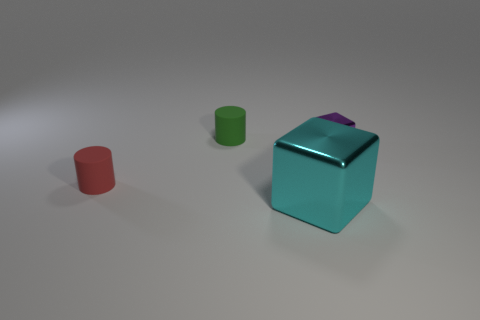There is a purple thing; is its size the same as the rubber cylinder that is behind the small purple metallic thing?
Provide a succinct answer. Yes. There is a cylinder on the right side of the small red rubber cylinder behind the cyan shiny thing; what is its color?
Keep it short and to the point. Green. Are there the same number of small purple metallic cubes in front of the tiny purple cube and purple metal cubes that are to the left of the cyan object?
Your answer should be very brief. Yes. Are the tiny cylinder that is in front of the tiny green thing and the large cyan block made of the same material?
Your answer should be very brief. No. There is a object that is left of the cyan block and behind the red rubber thing; what color is it?
Provide a succinct answer. Green. There is a small thing that is to the right of the cyan metallic object; how many tiny cylinders are in front of it?
Your answer should be very brief. 1. There is another object that is the same shape as the big cyan metallic thing; what material is it?
Ensure brevity in your answer.  Metal. What is the color of the big metal block?
Make the answer very short. Cyan. What number of objects are either small red matte cylinders or large gray cubes?
Offer a very short reply. 1. There is a matte thing to the left of the rubber thing behind the tiny purple block; what is its shape?
Your response must be concise. Cylinder. 